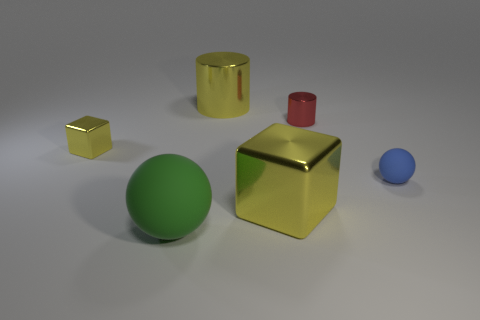Is the number of tiny blue things greater than the number of tiny yellow rubber cubes? yes 